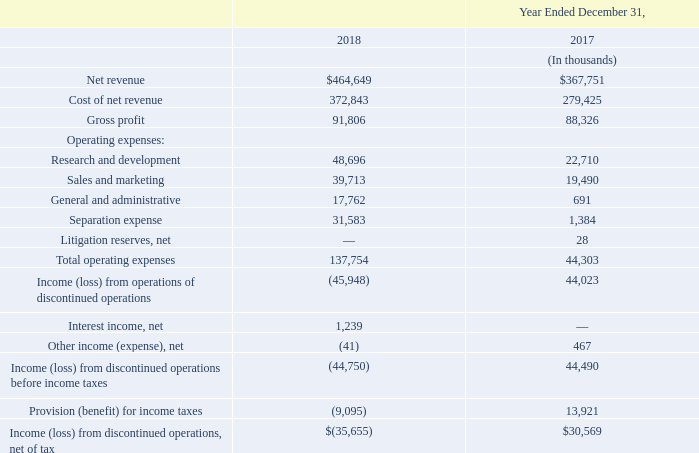On February 6, 2018, the Company announced that its Board of Directors had unanimously approved the pursuit of a separation of its smart camera business “Arlo” from NETGEAR (the “Separation”) to be effected by way of initial public offering (“IPO”) and spin-off. On August 2, 2018, Arlo Technologies, Inc. (“Arlo”) and NETGEAR announced the pricing of Arlo's initial public offering (“IPO”) at a price to the public of $16.00 per share, subsequently listing on the New York Stock Exchange on August 3, 2018 under the symbol "ARLO". On August 7, Arlo completed the IPO and generated proceeds of approximately $170.2 million, net of offering costs, which Arlo used for its general corporate purposes. Upon completion of the IPO, Arlo common stock outstanding amounted to 74,247,000 shares, of which NETGEAR held 62,500,000 shares, representing approximately 84.2% of the outstanding shares of Arlo common stock. On December 31, 2018, NETGEAR completed the distribution of these 62,500,000 shares of common stock of Arlo (the “Distribution”). After the completion of the Distribution, NETGEAR no longer owns any shares of Arlo common stock. The Distribution took place by way of a pro rata common stock dividend to each NETGEAR stockholder of record on the record date of the Distribution, December 17, 2018, and NETGEAR stockholders received 1.980295 shares of Arlo common stock for every share of NETGEAR common stock held as of the record date.
Upon completion of the Distribution, the Company ceased to own a controlling financial interest in Arlo and Arlo's assets, liabilities, operating results and cash flows for all periods presented have been classified as discontinued operations within the Consolidated Financial Statements.
In connection with Arlo's Separation, the Company incurred Separation expense of $34.2 million since commencing in December 2017. Separation expense primarily consists of third-party advisory, consulting, legal and professional services, IT costs and employee bonuses directly related to the separation, as well as other items that are incremental and one-time in nature that are related to the separation. The majority of these costs are reflected in the Company's consolidated statement of operations as discontinued operations for all periods presented. In addition, in the third fiscal quarter of 2018, the Company contributed $70.0 million in cash to Arlo and provided for, among other things, the transfer from NETGEAR to Arlo of assets and the assumption by Arlo of liabilities comprising its business effected through a master separation agreement between NETGEAR and Arlo. The master separation agreement governs the separation of Arlo's business from NETGEAR as well as various interim arrangements. In connection with these arrangements, during the third and fourth quarter of 2018, NETGEAR recorded a reduction to operating expenses of $6.3 million relating to the transition services, which are reflected in the Company's consolidated statement of operations as discontinued operations for the periods presented. In the third quarter of 2018, NETGEAR provided billing and collection services to Arlo in respect of its trade receivables and trade payments. As of December 31, 2018, NETGEAR had a net liability to Arlo of $12.2 million relating to these transition service, billing and collection services, and the net liability was classified within accounts payable on the consolidated balance sheets. The Company does not expect the amounts relating to such services to be material after the Distribution. Additionally, the Company entered into certain other agreements that provide a framework for the relationship between NETGEAR and Arlo after the separation, including a transition services agreement, a tax matters agreement, an employee matters agreement, an intellectual property rights cross-license agreement, and a registration rights agreement. In connection with Arlo's Separation, the Company incurred Separation expense of $34.2 million since commencing in December 2017. Separation expense primarily consists of third-party advisory, consulting, legal and professional services, IT costs and employee bonuses directly related to the separation, as well as other items that are incremental and one-time in nature that are related to the separation. The majority of these costs are reflected in the Company's consolidated statement of operations as discontinued operations for all periods presented. In addition, in the third fiscal quarter of 2018, the Company contributed $70.0 million in cash to Arlo and provided for, among other things, the transfer from NETGEAR to Arlo of assets and the assumption by Arlo of liabilities comprising its business effected through a master separation agreement between NETGEAR and Arlo. The master separation agreement governs the separation of Arlo's business from NETGEAR as well as various interim arrangements. In connection with these arrangements, during the third and fourth quarter of 2018, NETGEAR recorded a reduction to operating expenses of $6.3 million relating to the transition services, which are reflected in the Company's consolidated statement of operations as discontinued operations for the periods presented. In the third quarter of 2018, NETGEAR provided billing and collection services to Arlo in respect of its trade receivables and trade payments. As of December 31, 2018, NETGEAR had a net liability to Arlo of $12.2 million relating to these transition service, billing and collection services, and the net liability was classified within accounts payable on the consolidated balance sheets. The Company does not expect the amounts relating to such services to be material after the Distribution. Additionally, the Company entered into certain other agreements that provide a framework for the relationship between NETGEAR and Arlo after the separation, including a transition services agreement, a tax matters agreement, an employee matters agreement, an intellectual property rights cross-license agreement, and a registration rights agreement.
The financial results of Arlo through the Distribution date are presented as income (loss) from discontinued operations, net of tax, in the consolidated
statements of operations. The following table presents financial results of Arlo:
How many percent of outstanding shares of Arlo common stock does NETGEAR hold before the distribution? 84.2%. What was the net liability to Arlo in 2018? $12.2 million. What was Arlo's initial public offering share price? 16. Which year has a lower total operating expense? 44,303 < 137,754
Answer: 2017. What was the percentage change in net revenue from 2017 to 2018?
Answer scale should be: percent. ($464,649 - $367,751)/$367,751 
Answer: 26.35. How many components does the operating expenses consist of? Research and development ## Sales and marketing ## General and administrative ## Separation expense ## Litigation reserves, net
Answer: 5. 